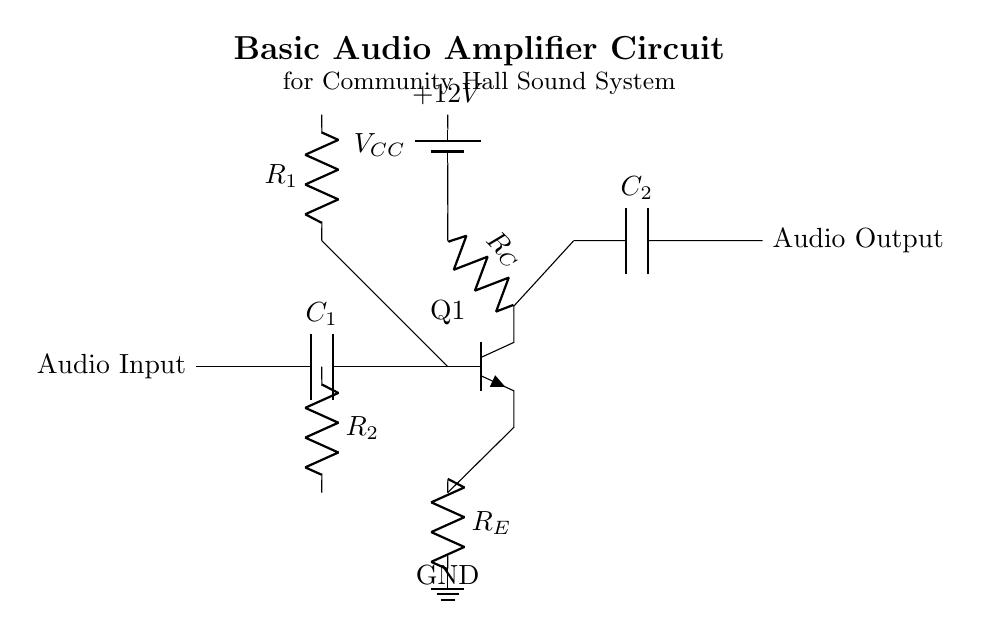What is the type of transistor used in this amplifier? The circuit diagram shows an NPn transistor labeled Q1, which is indicated by the notation near the transistor symbol.
Answer: NPn What is the value of the supply voltage in this circuit? The circuit diagram indicates a battery labeled with +12V, which is the voltage supplied to the circuit.
Answer: 12V What component is used to block DC while allowing AC signals to pass at the input? The diagram features a capacitor labeled C1 at the input, which is designed to block DC voltage while allowing AC audio signals to pass through.
Answer: Capacitor What is the purpose of the resistor labeled R_E? R_E is the emitter resistor, and it is used to stabilize the operating point of the transistor, helping to improve linearity and thermal stability.
Answer: Stabilization How many resistors are present in the circuit, and what are their labels? The circuit contains three resistors labeled as R_C, R_1, and R_2, which control different aspects of the amplifier's operation.
Answer: Three (R_C, R_1, R_2) What type of signals does this audio amplifier circuit output? The output of this circuit, which is indicated after the output capacitor C2, is an amplified AC audio signal suitable for driving speakers.
Answer: AC audio signals What role does capacitor C2 play in the output stage of the amplifier? C2 serves to block any DC component from reaching the output while allowing the amplified AC audio signal to pass to the speakers or subsequent stages.
Answer: Blocking DC 